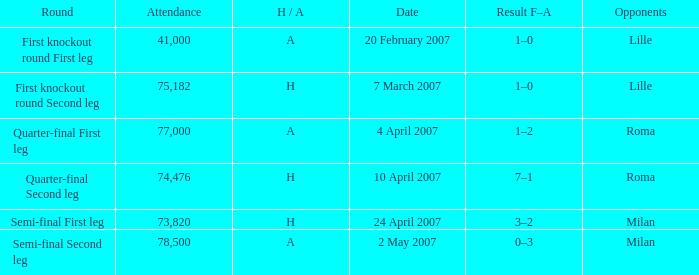How many people attended on 2 may 2007? 78500.0. 